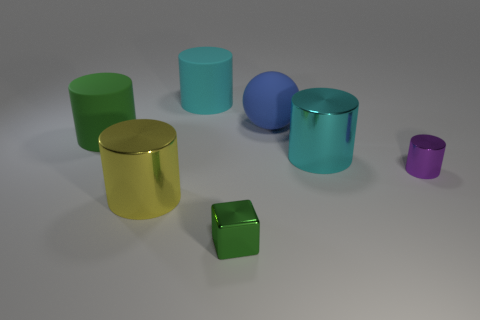Subtract all green cylinders. How many cylinders are left? 4 Subtract all green rubber cylinders. How many cylinders are left? 4 Subtract all green cylinders. Subtract all green balls. How many cylinders are left? 4 Add 1 balls. How many objects exist? 8 Subtract all cylinders. How many objects are left? 2 Add 7 green matte cylinders. How many green matte cylinders are left? 8 Add 2 tiny cubes. How many tiny cubes exist? 3 Subtract 0 red cubes. How many objects are left? 7 Subtract all big yellow metallic objects. Subtract all large cyan metallic cylinders. How many objects are left? 5 